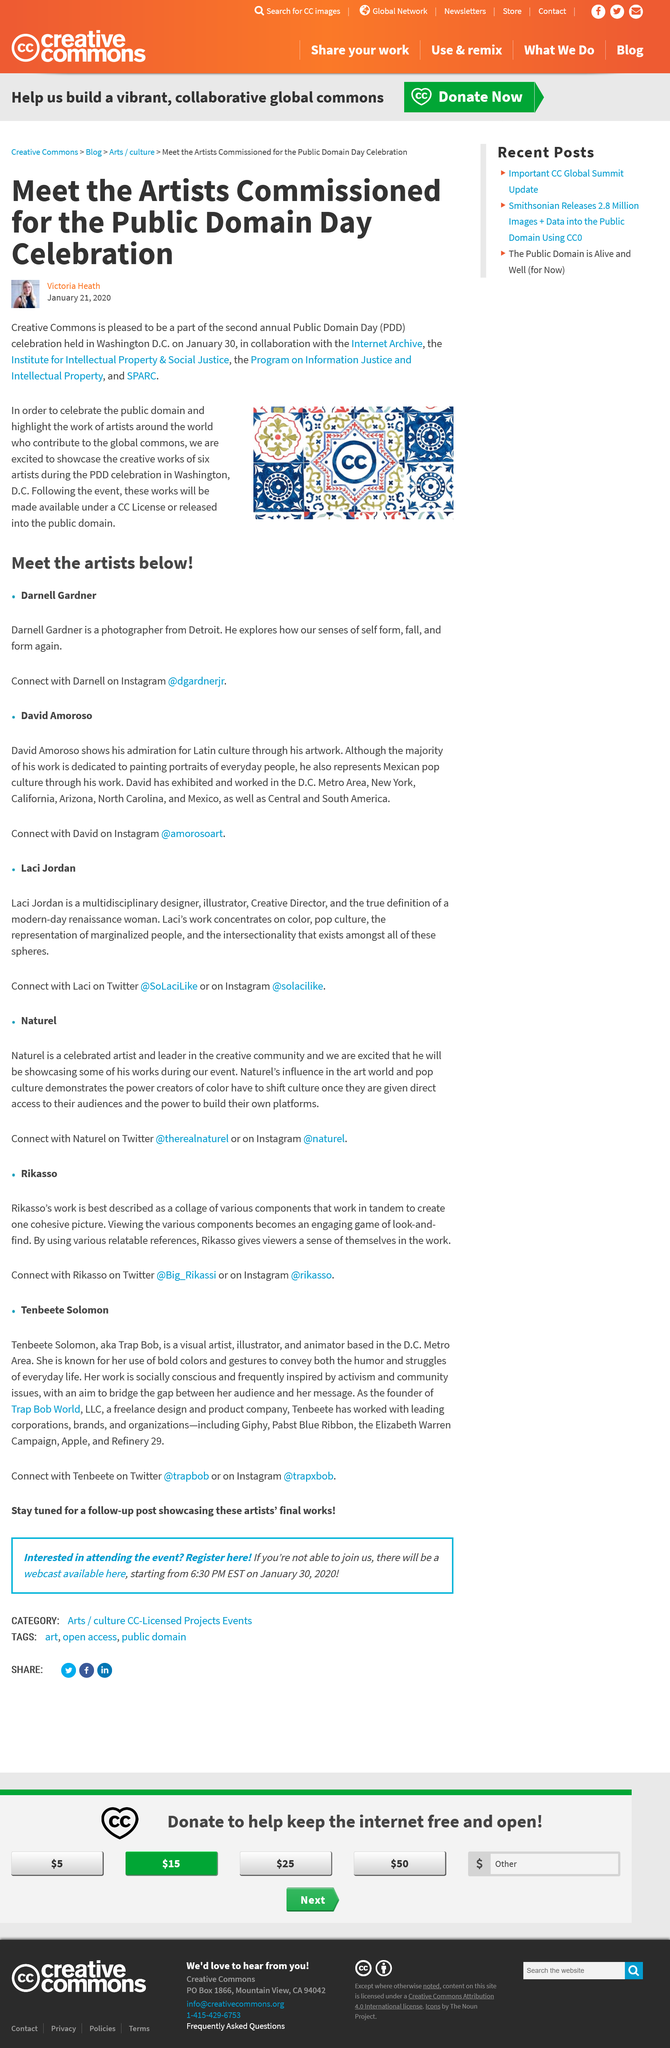Specify some key components in this picture. In 2020, the article was published. Tanbeete Solomon's work is frequently inspired by activism and community issues, and her art reflects a deep commitment to social justice and equality. Tanbeete Solomon has collaborated with several leading brands and corporations, including Giphy, Pabst Blue Ribbon, the Elizabeth Warren Campaign, Apple, and Refinery 29. Public Domain Day celebrates the expiration of copyright protection for certain works and is an event that recognizes the contributions of authors and creators. The name of the author is Victoria Heath. 